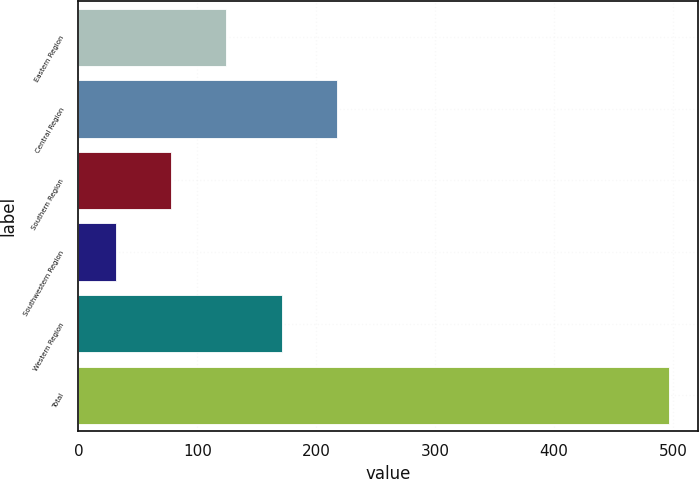<chart> <loc_0><loc_0><loc_500><loc_500><bar_chart><fcel>Eastern Region<fcel>Central Region<fcel>Southern Region<fcel>Southwestern Region<fcel>Western Region<fcel>Total<nl><fcel>124.28<fcel>217.36<fcel>77.74<fcel>31.2<fcel>170.82<fcel>496.6<nl></chart> 